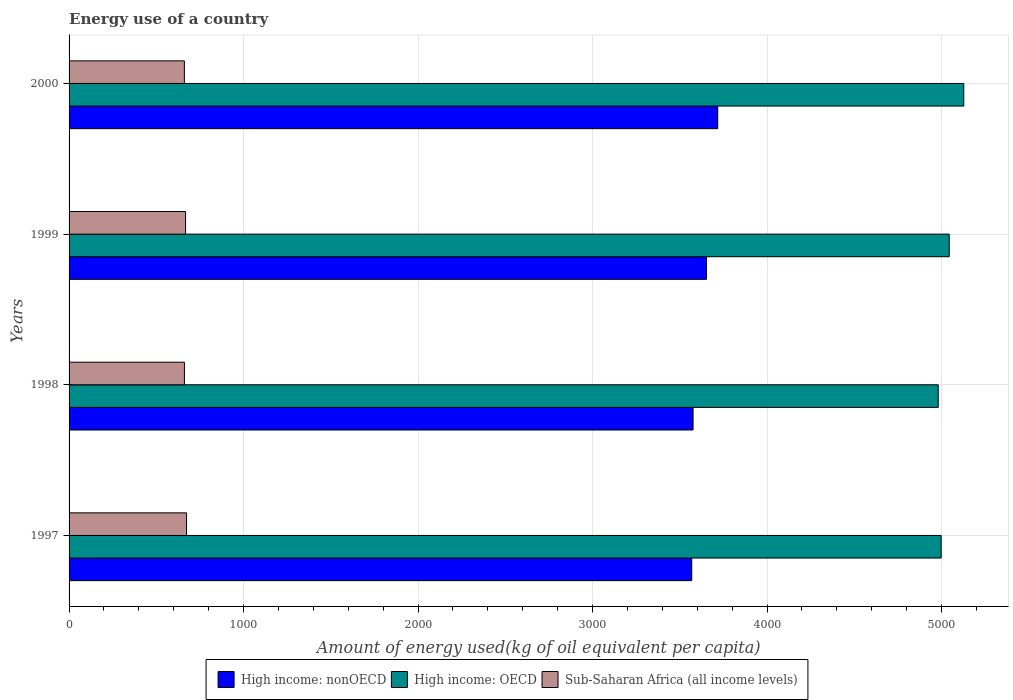How many different coloured bars are there?
Your answer should be very brief. 3. How many groups of bars are there?
Provide a short and direct response. 4. How many bars are there on the 3rd tick from the top?
Make the answer very short. 3. How many bars are there on the 2nd tick from the bottom?
Your response must be concise. 3. What is the label of the 2nd group of bars from the top?
Offer a very short reply. 1999. What is the amount of energy used in in High income: OECD in 1999?
Your response must be concise. 5044.24. Across all years, what is the maximum amount of energy used in in Sub-Saharan Africa (all income levels)?
Your answer should be very brief. 673.28. Across all years, what is the minimum amount of energy used in in High income: OECD?
Your answer should be very brief. 4981.34. In which year was the amount of energy used in in High income: OECD maximum?
Your answer should be very brief. 2000. What is the total amount of energy used in in High income: OECD in the graph?
Offer a terse response. 2.02e+04. What is the difference between the amount of energy used in in High income: nonOECD in 1997 and that in 2000?
Offer a terse response. -149.02. What is the difference between the amount of energy used in in High income: OECD in 1997 and the amount of energy used in in Sub-Saharan Africa (all income levels) in 1998?
Offer a terse response. 4337. What is the average amount of energy used in in High income: nonOECD per year?
Your response must be concise. 3628.85. In the year 2000, what is the difference between the amount of energy used in in Sub-Saharan Africa (all income levels) and amount of energy used in in High income: nonOECD?
Provide a succinct answer. -3056.76. What is the ratio of the amount of energy used in in High income: OECD in 1999 to that in 2000?
Give a very brief answer. 0.98. Is the amount of energy used in in High income: OECD in 1997 less than that in 1999?
Provide a short and direct response. Yes. What is the difference between the highest and the second highest amount of energy used in in Sub-Saharan Africa (all income levels)?
Offer a very short reply. 5.61. What is the difference between the highest and the lowest amount of energy used in in Sub-Saharan Africa (all income levels)?
Keep it short and to the point. 12.5. Is the sum of the amount of energy used in in High income: OECD in 1997 and 1998 greater than the maximum amount of energy used in in Sub-Saharan Africa (all income levels) across all years?
Make the answer very short. Yes. What does the 3rd bar from the top in 1999 represents?
Your response must be concise. High income: nonOECD. What does the 2nd bar from the bottom in 1999 represents?
Keep it short and to the point. High income: OECD. Are all the bars in the graph horizontal?
Offer a terse response. Yes. Are the values on the major ticks of X-axis written in scientific E-notation?
Your response must be concise. No. Where does the legend appear in the graph?
Your response must be concise. Bottom center. How are the legend labels stacked?
Offer a very short reply. Horizontal. What is the title of the graph?
Your answer should be very brief. Energy use of a country. What is the label or title of the X-axis?
Give a very brief answer. Amount of energy used(kg of oil equivalent per capita). What is the label or title of the Y-axis?
Give a very brief answer. Years. What is the Amount of energy used(kg of oil equivalent per capita) of High income: nonOECD in 1997?
Your response must be concise. 3568.52. What is the Amount of energy used(kg of oil equivalent per capita) in High income: OECD in 1997?
Your answer should be compact. 4998.13. What is the Amount of energy used(kg of oil equivalent per capita) of Sub-Saharan Africa (all income levels) in 1997?
Your response must be concise. 673.28. What is the Amount of energy used(kg of oil equivalent per capita) of High income: nonOECD in 1998?
Your response must be concise. 3576.2. What is the Amount of energy used(kg of oil equivalent per capita) in High income: OECD in 1998?
Offer a terse response. 4981.34. What is the Amount of energy used(kg of oil equivalent per capita) in Sub-Saharan Africa (all income levels) in 1998?
Ensure brevity in your answer.  661.13. What is the Amount of energy used(kg of oil equivalent per capita) in High income: nonOECD in 1999?
Your answer should be very brief. 3653.14. What is the Amount of energy used(kg of oil equivalent per capita) in High income: OECD in 1999?
Offer a very short reply. 5044.24. What is the Amount of energy used(kg of oil equivalent per capita) of Sub-Saharan Africa (all income levels) in 1999?
Ensure brevity in your answer.  667.67. What is the Amount of energy used(kg of oil equivalent per capita) in High income: nonOECD in 2000?
Offer a terse response. 3717.54. What is the Amount of energy used(kg of oil equivalent per capita) in High income: OECD in 2000?
Keep it short and to the point. 5127.59. What is the Amount of energy used(kg of oil equivalent per capita) of Sub-Saharan Africa (all income levels) in 2000?
Your answer should be very brief. 660.78. Across all years, what is the maximum Amount of energy used(kg of oil equivalent per capita) of High income: nonOECD?
Offer a very short reply. 3717.54. Across all years, what is the maximum Amount of energy used(kg of oil equivalent per capita) in High income: OECD?
Your answer should be compact. 5127.59. Across all years, what is the maximum Amount of energy used(kg of oil equivalent per capita) of Sub-Saharan Africa (all income levels)?
Your answer should be compact. 673.28. Across all years, what is the minimum Amount of energy used(kg of oil equivalent per capita) of High income: nonOECD?
Provide a succinct answer. 3568.52. Across all years, what is the minimum Amount of energy used(kg of oil equivalent per capita) of High income: OECD?
Offer a terse response. 4981.34. Across all years, what is the minimum Amount of energy used(kg of oil equivalent per capita) of Sub-Saharan Africa (all income levels)?
Offer a very short reply. 660.78. What is the total Amount of energy used(kg of oil equivalent per capita) of High income: nonOECD in the graph?
Keep it short and to the point. 1.45e+04. What is the total Amount of energy used(kg of oil equivalent per capita) of High income: OECD in the graph?
Your answer should be very brief. 2.02e+04. What is the total Amount of energy used(kg of oil equivalent per capita) in Sub-Saharan Africa (all income levels) in the graph?
Keep it short and to the point. 2662.86. What is the difference between the Amount of energy used(kg of oil equivalent per capita) in High income: nonOECD in 1997 and that in 1998?
Your answer should be compact. -7.68. What is the difference between the Amount of energy used(kg of oil equivalent per capita) of High income: OECD in 1997 and that in 1998?
Make the answer very short. 16.8. What is the difference between the Amount of energy used(kg of oil equivalent per capita) in Sub-Saharan Africa (all income levels) in 1997 and that in 1998?
Your answer should be very brief. 12.14. What is the difference between the Amount of energy used(kg of oil equivalent per capita) in High income: nonOECD in 1997 and that in 1999?
Ensure brevity in your answer.  -84.62. What is the difference between the Amount of energy used(kg of oil equivalent per capita) of High income: OECD in 1997 and that in 1999?
Provide a succinct answer. -46.1. What is the difference between the Amount of energy used(kg of oil equivalent per capita) of Sub-Saharan Africa (all income levels) in 1997 and that in 1999?
Ensure brevity in your answer.  5.61. What is the difference between the Amount of energy used(kg of oil equivalent per capita) in High income: nonOECD in 1997 and that in 2000?
Keep it short and to the point. -149.02. What is the difference between the Amount of energy used(kg of oil equivalent per capita) of High income: OECD in 1997 and that in 2000?
Offer a terse response. -129.46. What is the difference between the Amount of energy used(kg of oil equivalent per capita) of Sub-Saharan Africa (all income levels) in 1997 and that in 2000?
Provide a short and direct response. 12.49. What is the difference between the Amount of energy used(kg of oil equivalent per capita) in High income: nonOECD in 1998 and that in 1999?
Provide a short and direct response. -76.94. What is the difference between the Amount of energy used(kg of oil equivalent per capita) in High income: OECD in 1998 and that in 1999?
Make the answer very short. -62.9. What is the difference between the Amount of energy used(kg of oil equivalent per capita) in Sub-Saharan Africa (all income levels) in 1998 and that in 1999?
Provide a succinct answer. -6.53. What is the difference between the Amount of energy used(kg of oil equivalent per capita) in High income: nonOECD in 1998 and that in 2000?
Offer a very short reply. -141.34. What is the difference between the Amount of energy used(kg of oil equivalent per capita) in High income: OECD in 1998 and that in 2000?
Offer a very short reply. -146.25. What is the difference between the Amount of energy used(kg of oil equivalent per capita) of Sub-Saharan Africa (all income levels) in 1998 and that in 2000?
Offer a terse response. 0.35. What is the difference between the Amount of energy used(kg of oil equivalent per capita) of High income: nonOECD in 1999 and that in 2000?
Your answer should be compact. -64.4. What is the difference between the Amount of energy used(kg of oil equivalent per capita) in High income: OECD in 1999 and that in 2000?
Provide a succinct answer. -83.36. What is the difference between the Amount of energy used(kg of oil equivalent per capita) of Sub-Saharan Africa (all income levels) in 1999 and that in 2000?
Offer a very short reply. 6.88. What is the difference between the Amount of energy used(kg of oil equivalent per capita) in High income: nonOECD in 1997 and the Amount of energy used(kg of oil equivalent per capita) in High income: OECD in 1998?
Your answer should be very brief. -1412.82. What is the difference between the Amount of energy used(kg of oil equivalent per capita) in High income: nonOECD in 1997 and the Amount of energy used(kg of oil equivalent per capita) in Sub-Saharan Africa (all income levels) in 1998?
Make the answer very short. 2907.39. What is the difference between the Amount of energy used(kg of oil equivalent per capita) in High income: OECD in 1997 and the Amount of energy used(kg of oil equivalent per capita) in Sub-Saharan Africa (all income levels) in 1998?
Your answer should be very brief. 4337. What is the difference between the Amount of energy used(kg of oil equivalent per capita) of High income: nonOECD in 1997 and the Amount of energy used(kg of oil equivalent per capita) of High income: OECD in 1999?
Your response must be concise. -1475.72. What is the difference between the Amount of energy used(kg of oil equivalent per capita) of High income: nonOECD in 1997 and the Amount of energy used(kg of oil equivalent per capita) of Sub-Saharan Africa (all income levels) in 1999?
Your response must be concise. 2900.85. What is the difference between the Amount of energy used(kg of oil equivalent per capita) in High income: OECD in 1997 and the Amount of energy used(kg of oil equivalent per capita) in Sub-Saharan Africa (all income levels) in 1999?
Ensure brevity in your answer.  4330.47. What is the difference between the Amount of energy used(kg of oil equivalent per capita) of High income: nonOECD in 1997 and the Amount of energy used(kg of oil equivalent per capita) of High income: OECD in 2000?
Ensure brevity in your answer.  -1559.07. What is the difference between the Amount of energy used(kg of oil equivalent per capita) of High income: nonOECD in 1997 and the Amount of energy used(kg of oil equivalent per capita) of Sub-Saharan Africa (all income levels) in 2000?
Make the answer very short. 2907.74. What is the difference between the Amount of energy used(kg of oil equivalent per capita) of High income: OECD in 1997 and the Amount of energy used(kg of oil equivalent per capita) of Sub-Saharan Africa (all income levels) in 2000?
Provide a succinct answer. 4337.35. What is the difference between the Amount of energy used(kg of oil equivalent per capita) in High income: nonOECD in 1998 and the Amount of energy used(kg of oil equivalent per capita) in High income: OECD in 1999?
Provide a succinct answer. -1468.03. What is the difference between the Amount of energy used(kg of oil equivalent per capita) in High income: nonOECD in 1998 and the Amount of energy used(kg of oil equivalent per capita) in Sub-Saharan Africa (all income levels) in 1999?
Ensure brevity in your answer.  2908.54. What is the difference between the Amount of energy used(kg of oil equivalent per capita) of High income: OECD in 1998 and the Amount of energy used(kg of oil equivalent per capita) of Sub-Saharan Africa (all income levels) in 1999?
Your answer should be compact. 4313.67. What is the difference between the Amount of energy used(kg of oil equivalent per capita) in High income: nonOECD in 1998 and the Amount of energy used(kg of oil equivalent per capita) in High income: OECD in 2000?
Your response must be concise. -1551.39. What is the difference between the Amount of energy used(kg of oil equivalent per capita) in High income: nonOECD in 1998 and the Amount of energy used(kg of oil equivalent per capita) in Sub-Saharan Africa (all income levels) in 2000?
Offer a terse response. 2915.42. What is the difference between the Amount of energy used(kg of oil equivalent per capita) of High income: OECD in 1998 and the Amount of energy used(kg of oil equivalent per capita) of Sub-Saharan Africa (all income levels) in 2000?
Keep it short and to the point. 4320.56. What is the difference between the Amount of energy used(kg of oil equivalent per capita) of High income: nonOECD in 1999 and the Amount of energy used(kg of oil equivalent per capita) of High income: OECD in 2000?
Provide a short and direct response. -1474.45. What is the difference between the Amount of energy used(kg of oil equivalent per capita) in High income: nonOECD in 1999 and the Amount of energy used(kg of oil equivalent per capita) in Sub-Saharan Africa (all income levels) in 2000?
Provide a short and direct response. 2992.36. What is the difference between the Amount of energy used(kg of oil equivalent per capita) of High income: OECD in 1999 and the Amount of energy used(kg of oil equivalent per capita) of Sub-Saharan Africa (all income levels) in 2000?
Ensure brevity in your answer.  4383.45. What is the average Amount of energy used(kg of oil equivalent per capita) in High income: nonOECD per year?
Give a very brief answer. 3628.85. What is the average Amount of energy used(kg of oil equivalent per capita) of High income: OECD per year?
Your answer should be very brief. 5037.83. What is the average Amount of energy used(kg of oil equivalent per capita) of Sub-Saharan Africa (all income levels) per year?
Offer a very short reply. 665.72. In the year 1997, what is the difference between the Amount of energy used(kg of oil equivalent per capita) in High income: nonOECD and Amount of energy used(kg of oil equivalent per capita) in High income: OECD?
Provide a succinct answer. -1429.61. In the year 1997, what is the difference between the Amount of energy used(kg of oil equivalent per capita) in High income: nonOECD and Amount of energy used(kg of oil equivalent per capita) in Sub-Saharan Africa (all income levels)?
Provide a succinct answer. 2895.24. In the year 1997, what is the difference between the Amount of energy used(kg of oil equivalent per capita) in High income: OECD and Amount of energy used(kg of oil equivalent per capita) in Sub-Saharan Africa (all income levels)?
Your answer should be compact. 4324.86. In the year 1998, what is the difference between the Amount of energy used(kg of oil equivalent per capita) in High income: nonOECD and Amount of energy used(kg of oil equivalent per capita) in High income: OECD?
Your response must be concise. -1405.14. In the year 1998, what is the difference between the Amount of energy used(kg of oil equivalent per capita) in High income: nonOECD and Amount of energy used(kg of oil equivalent per capita) in Sub-Saharan Africa (all income levels)?
Offer a terse response. 2915.07. In the year 1998, what is the difference between the Amount of energy used(kg of oil equivalent per capita) in High income: OECD and Amount of energy used(kg of oil equivalent per capita) in Sub-Saharan Africa (all income levels)?
Offer a terse response. 4320.21. In the year 1999, what is the difference between the Amount of energy used(kg of oil equivalent per capita) in High income: nonOECD and Amount of energy used(kg of oil equivalent per capita) in High income: OECD?
Your response must be concise. -1391.1. In the year 1999, what is the difference between the Amount of energy used(kg of oil equivalent per capita) in High income: nonOECD and Amount of energy used(kg of oil equivalent per capita) in Sub-Saharan Africa (all income levels)?
Offer a very short reply. 2985.47. In the year 1999, what is the difference between the Amount of energy used(kg of oil equivalent per capita) of High income: OECD and Amount of energy used(kg of oil equivalent per capita) of Sub-Saharan Africa (all income levels)?
Provide a succinct answer. 4376.57. In the year 2000, what is the difference between the Amount of energy used(kg of oil equivalent per capita) of High income: nonOECD and Amount of energy used(kg of oil equivalent per capita) of High income: OECD?
Offer a terse response. -1410.05. In the year 2000, what is the difference between the Amount of energy used(kg of oil equivalent per capita) of High income: nonOECD and Amount of energy used(kg of oil equivalent per capita) of Sub-Saharan Africa (all income levels)?
Keep it short and to the point. 3056.76. In the year 2000, what is the difference between the Amount of energy used(kg of oil equivalent per capita) of High income: OECD and Amount of energy used(kg of oil equivalent per capita) of Sub-Saharan Africa (all income levels)?
Provide a succinct answer. 4466.81. What is the ratio of the Amount of energy used(kg of oil equivalent per capita) in Sub-Saharan Africa (all income levels) in 1997 to that in 1998?
Give a very brief answer. 1.02. What is the ratio of the Amount of energy used(kg of oil equivalent per capita) in High income: nonOECD in 1997 to that in 1999?
Provide a short and direct response. 0.98. What is the ratio of the Amount of energy used(kg of oil equivalent per capita) of High income: OECD in 1997 to that in 1999?
Offer a very short reply. 0.99. What is the ratio of the Amount of energy used(kg of oil equivalent per capita) of Sub-Saharan Africa (all income levels) in 1997 to that in 1999?
Your answer should be compact. 1.01. What is the ratio of the Amount of energy used(kg of oil equivalent per capita) in High income: nonOECD in 1997 to that in 2000?
Your response must be concise. 0.96. What is the ratio of the Amount of energy used(kg of oil equivalent per capita) in High income: OECD in 1997 to that in 2000?
Make the answer very short. 0.97. What is the ratio of the Amount of energy used(kg of oil equivalent per capita) in Sub-Saharan Africa (all income levels) in 1997 to that in 2000?
Provide a short and direct response. 1.02. What is the ratio of the Amount of energy used(kg of oil equivalent per capita) in High income: nonOECD in 1998 to that in 1999?
Your answer should be very brief. 0.98. What is the ratio of the Amount of energy used(kg of oil equivalent per capita) in High income: OECD in 1998 to that in 1999?
Keep it short and to the point. 0.99. What is the ratio of the Amount of energy used(kg of oil equivalent per capita) in Sub-Saharan Africa (all income levels) in 1998 to that in 1999?
Give a very brief answer. 0.99. What is the ratio of the Amount of energy used(kg of oil equivalent per capita) in High income: OECD in 1998 to that in 2000?
Provide a short and direct response. 0.97. What is the ratio of the Amount of energy used(kg of oil equivalent per capita) in High income: nonOECD in 1999 to that in 2000?
Keep it short and to the point. 0.98. What is the ratio of the Amount of energy used(kg of oil equivalent per capita) in High income: OECD in 1999 to that in 2000?
Give a very brief answer. 0.98. What is the ratio of the Amount of energy used(kg of oil equivalent per capita) in Sub-Saharan Africa (all income levels) in 1999 to that in 2000?
Offer a very short reply. 1.01. What is the difference between the highest and the second highest Amount of energy used(kg of oil equivalent per capita) of High income: nonOECD?
Offer a very short reply. 64.4. What is the difference between the highest and the second highest Amount of energy used(kg of oil equivalent per capita) of High income: OECD?
Provide a short and direct response. 83.36. What is the difference between the highest and the second highest Amount of energy used(kg of oil equivalent per capita) of Sub-Saharan Africa (all income levels)?
Keep it short and to the point. 5.61. What is the difference between the highest and the lowest Amount of energy used(kg of oil equivalent per capita) in High income: nonOECD?
Keep it short and to the point. 149.02. What is the difference between the highest and the lowest Amount of energy used(kg of oil equivalent per capita) of High income: OECD?
Keep it short and to the point. 146.25. What is the difference between the highest and the lowest Amount of energy used(kg of oil equivalent per capita) of Sub-Saharan Africa (all income levels)?
Ensure brevity in your answer.  12.49. 